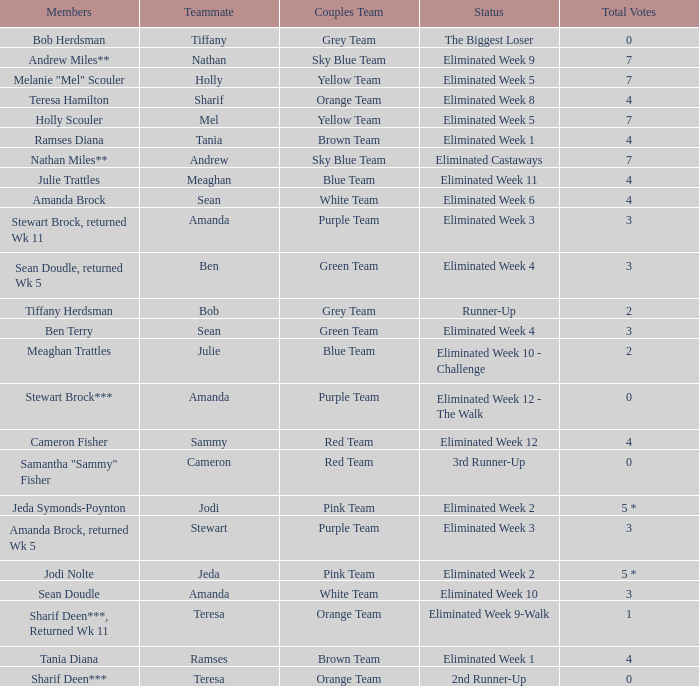What was holly scouler's complete votes? 7.0. 